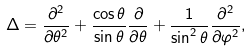<formula> <loc_0><loc_0><loc_500><loc_500>\Delta = \frac { \partial ^ { 2 } } { \partial \theta ^ { 2 } } + \frac { \cos \theta } { \sin \theta } \frac { \partial } { \partial \theta } + \frac { 1 } { \sin ^ { 2 } \theta } \frac { \partial ^ { 2 } } { \partial \varphi ^ { 2 } } ,</formula> 